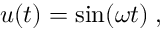Convert formula to latex. <formula><loc_0><loc_0><loc_500><loc_500>u ( t ) = \sin ( \omega t ) \, ,</formula> 